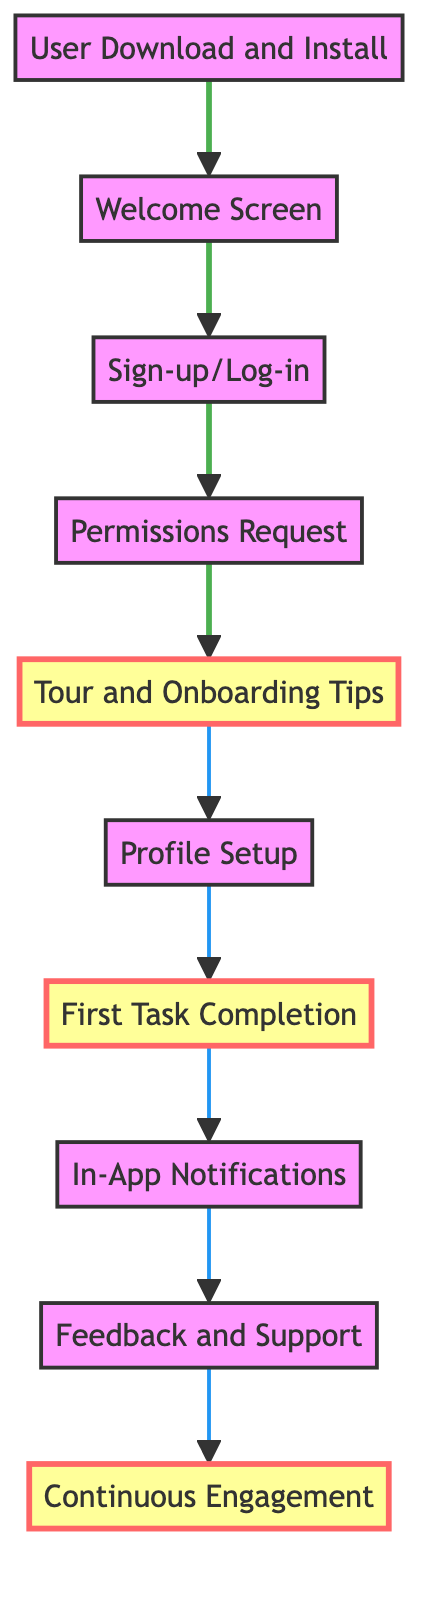What is the first step in the user onboarding process? The first step in the process is represented by the bottom node labeled "User Download and Install." This indicates that users must first download and install the app before progressing to any other steps.
Answer: User Download and Install How many main steps are there in the user onboarding process? By counting the nodes in the diagram, from "User Download and Install" to "Continuous Engagement," we find a total of 10 steps involved in the onboarding process.
Answer: 10 What node follows the "Permissions Request"? In the flow, after the "Permissions Request," the next node is "Tour and Onboarding Tips," which provides users an introduction to the app's main features.
Answer: Tour and Onboarding Tips What is the last step in the user onboarding process? The last step, represented by the top node in the flow, is labeled "Continuous Engagement," which emphasizes the need for ongoing user interaction with the app.
Answer: Continuous Engagement How many nodes are highlighted in the diagram? Upon examining the diagram, we see that there are three highlighted nodes: "Tour and Onboarding Tips," "First Task Completion," and "Continuous Engagement." This indicates special importance or attention to these steps in the onboarding process.
Answer: 3 Which two nodes are focused on user interaction? The two nodes concerned with user interaction are "First Task Completion" and "Feedback and Support." These steps specifically engage users in completing tasks and providing feedback respectively, building a two-way relationship.
Answer: First Task Completion, Feedback and Support What does the "Welcome Screen" node represent in the onboarding process? The "Welcome Screen" serves as an introductory point, conveying the app's value proposition to new users, which is essential for creating an enticing first impression.
Answer: A friendly welcome screen Which steps require user input before proceeding to the next node? The steps "Sign-up/Log-in" and "Profile Setup" necessitate user input; users must create an account or log in, and then fill in personal information to continue through the onboarding process.
Answer: Sign-up/Log-in, Profile Setup What type of permissions are requested in the onboarding process? The "Permissions Request" node typically includes necessary permissions such as location and notifications, crucial for the app to function optimally and enhance user experience.
Answer: Location, notifications What is the purpose of the "In-App Notifications" node? "In-App Notifications" are designed to keep users informed about new features, updates, or tips directly within the app, thus facilitating continuous engagement and user retention.
Answer: Notify users about new features, updates or tips 